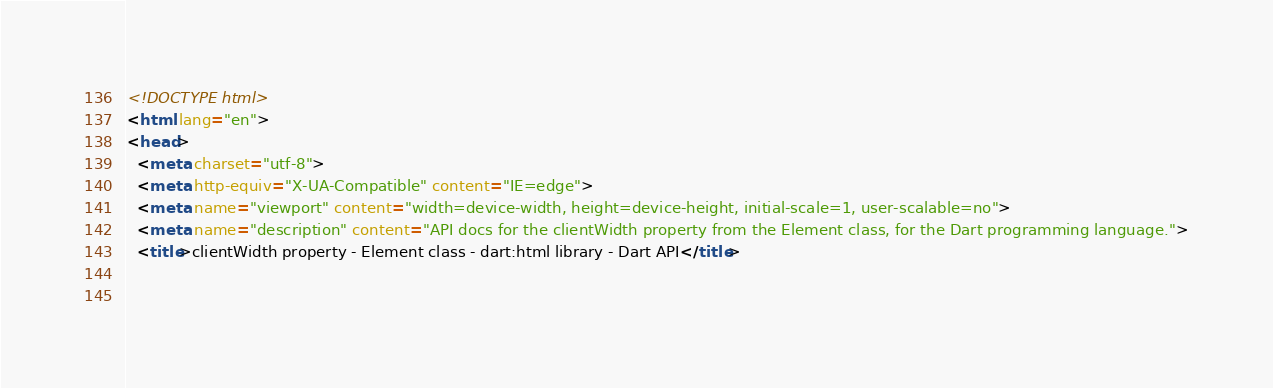Convert code to text. <code><loc_0><loc_0><loc_500><loc_500><_HTML_><!DOCTYPE html>
<html lang="en">
<head>
  <meta charset="utf-8">
  <meta http-equiv="X-UA-Compatible" content="IE=edge">
  <meta name="viewport" content="width=device-width, height=device-height, initial-scale=1, user-scalable=no">
  <meta name="description" content="API docs for the clientWidth property from the Element class, for the Dart programming language.">
  <title>clientWidth property - Element class - dart:html library - Dart API</title>

  </code> 